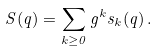<formula> <loc_0><loc_0><loc_500><loc_500>S ( q ) = \sum _ { k \geq 0 } g ^ { k } s _ { k } ( q ) \, .</formula> 